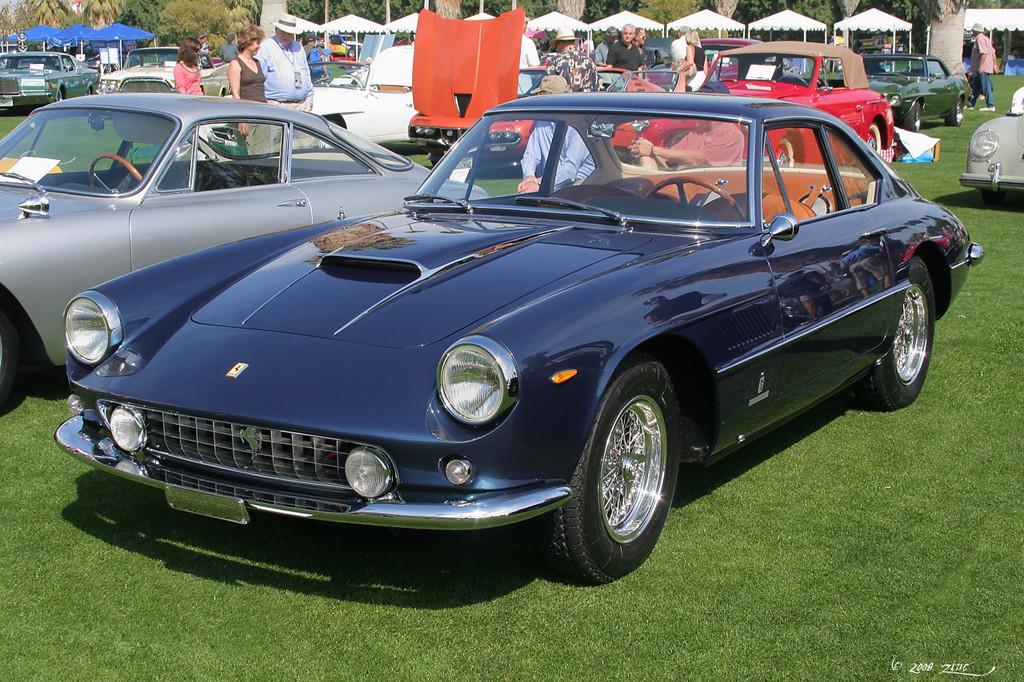Please provide a concise description of this image. In this picture there are cars in the center of the image and there is grassland at the bottom side of the image, there are umbrellas at the top side of the image. 